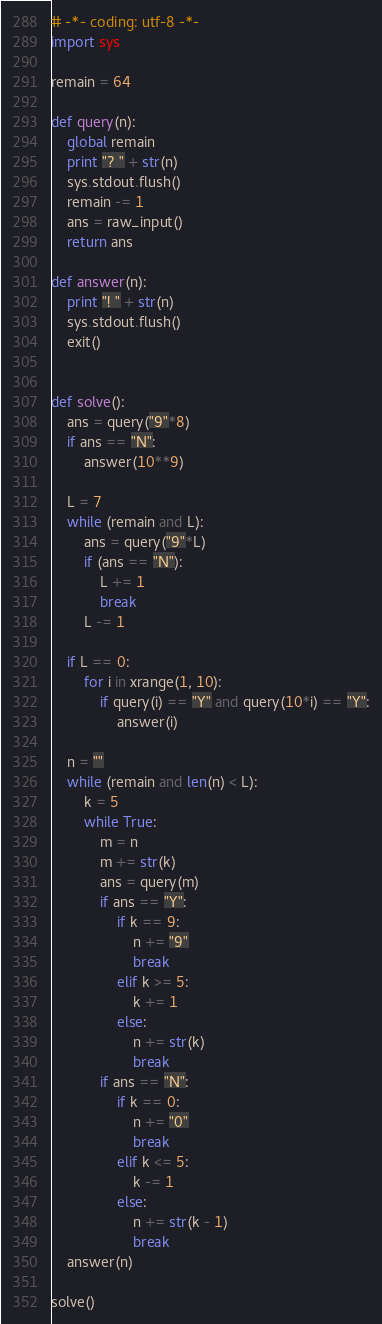<code> <loc_0><loc_0><loc_500><loc_500><_Python_># -*- coding: utf-8 -*-
import sys

remain = 64

def query(n):
    global remain
    print "? " + str(n)
    sys.stdout.flush()
    remain -= 1
    ans = raw_input()
    return ans

def answer(n):
    print "! " + str(n)
    sys.stdout.flush()
    exit()


def solve():
    ans = query("9"*8)
    if ans == "N":
        answer(10**9)

    L = 7
    while (remain and L):
        ans = query("9"*L)
        if (ans == "N"):
            L += 1
            break
        L -= 1

    if L == 0:
        for i in xrange(1, 10):
            if query(i) == "Y" and query(10*i) == "Y":
                answer(i)

    n = "" 
    while (remain and len(n) < L):
        k = 5
        while True:
            m = n
            m += str(k)
            ans = query(m)
            if ans == "Y":
                if k == 9:
                    n += "9"
                    break
                elif k >= 5:
                    k += 1
                else:
                    n += str(k) 
                    break
            if ans == "N":
                if k == 0:
                    n += "0"
                    break
                elif k <= 5:
                    k -= 1
                else:
                    n += str(k - 1)
                    break
    answer(n)

solve()
</code> 